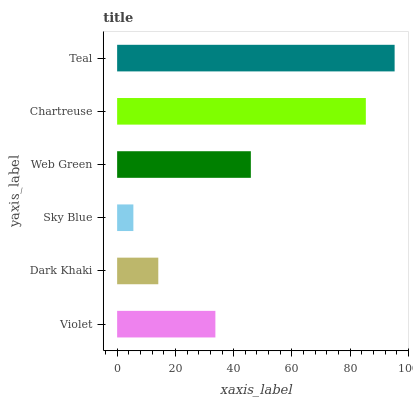Is Sky Blue the minimum?
Answer yes or no. Yes. Is Teal the maximum?
Answer yes or no. Yes. Is Dark Khaki the minimum?
Answer yes or no. No. Is Dark Khaki the maximum?
Answer yes or no. No. Is Violet greater than Dark Khaki?
Answer yes or no. Yes. Is Dark Khaki less than Violet?
Answer yes or no. Yes. Is Dark Khaki greater than Violet?
Answer yes or no. No. Is Violet less than Dark Khaki?
Answer yes or no. No. Is Web Green the high median?
Answer yes or no. Yes. Is Violet the low median?
Answer yes or no. Yes. Is Dark Khaki the high median?
Answer yes or no. No. Is Chartreuse the low median?
Answer yes or no. No. 